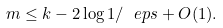<formula> <loc_0><loc_0><loc_500><loc_500>m \leq k - 2 \log 1 / \ e p s + O ( 1 ) .</formula> 